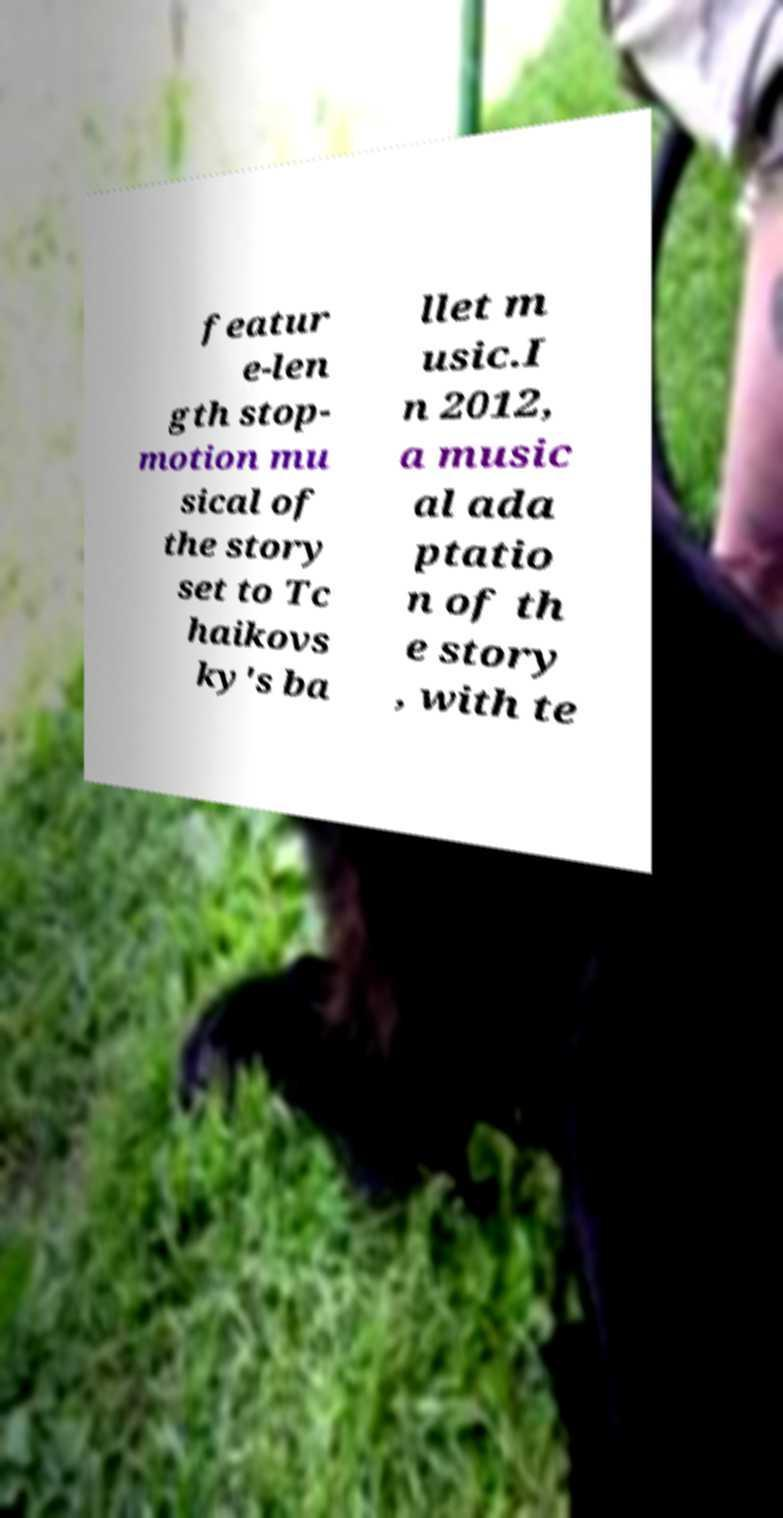Could you assist in decoding the text presented in this image and type it out clearly? featur e-len gth stop- motion mu sical of the story set to Tc haikovs ky's ba llet m usic.I n 2012, a music al ada ptatio n of th e story , with te 